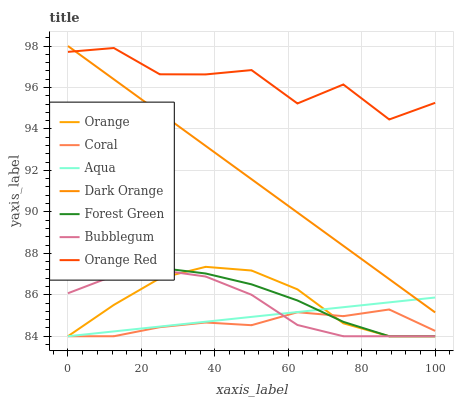Does Coral have the minimum area under the curve?
Answer yes or no. Yes. Does Orange Red have the maximum area under the curve?
Answer yes or no. Yes. Does Aqua have the minimum area under the curve?
Answer yes or no. No. Does Aqua have the maximum area under the curve?
Answer yes or no. No. Is Aqua the smoothest?
Answer yes or no. Yes. Is Orange Red the roughest?
Answer yes or no. Yes. Is Coral the smoothest?
Answer yes or no. No. Is Coral the roughest?
Answer yes or no. No. Does Coral have the lowest value?
Answer yes or no. Yes. Does Orange Red have the lowest value?
Answer yes or no. No. Does Dark Orange have the highest value?
Answer yes or no. Yes. Does Aqua have the highest value?
Answer yes or no. No. Is Aqua less than Orange Red?
Answer yes or no. Yes. Is Dark Orange greater than Orange?
Answer yes or no. Yes. Does Orange Red intersect Dark Orange?
Answer yes or no. Yes. Is Orange Red less than Dark Orange?
Answer yes or no. No. Is Orange Red greater than Dark Orange?
Answer yes or no. No. Does Aqua intersect Orange Red?
Answer yes or no. No. 